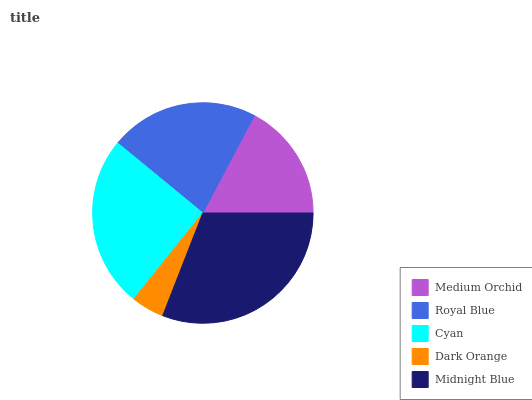Is Dark Orange the minimum?
Answer yes or no. Yes. Is Midnight Blue the maximum?
Answer yes or no. Yes. Is Royal Blue the minimum?
Answer yes or no. No. Is Royal Blue the maximum?
Answer yes or no. No. Is Royal Blue greater than Medium Orchid?
Answer yes or no. Yes. Is Medium Orchid less than Royal Blue?
Answer yes or no. Yes. Is Medium Orchid greater than Royal Blue?
Answer yes or no. No. Is Royal Blue less than Medium Orchid?
Answer yes or no. No. Is Royal Blue the high median?
Answer yes or no. Yes. Is Royal Blue the low median?
Answer yes or no. Yes. Is Medium Orchid the high median?
Answer yes or no. No. Is Medium Orchid the low median?
Answer yes or no. No. 